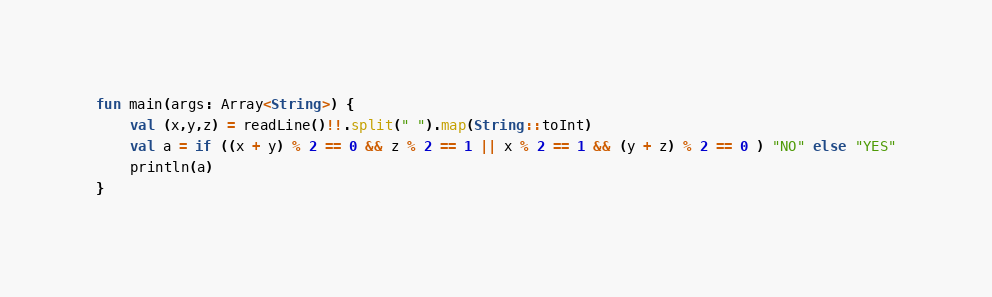Convert code to text. <code><loc_0><loc_0><loc_500><loc_500><_Kotlin_>fun main(args: Array<String>) {
    val (x,y,z) = readLine()!!.split(" ").map(String::toInt)
    val a = if ((x + y) % 2 == 0 && z % 2 == 1 || x % 2 == 1 && (y + z) % 2 == 0 ) "NO" else "YES"
    println(a)
}</code> 